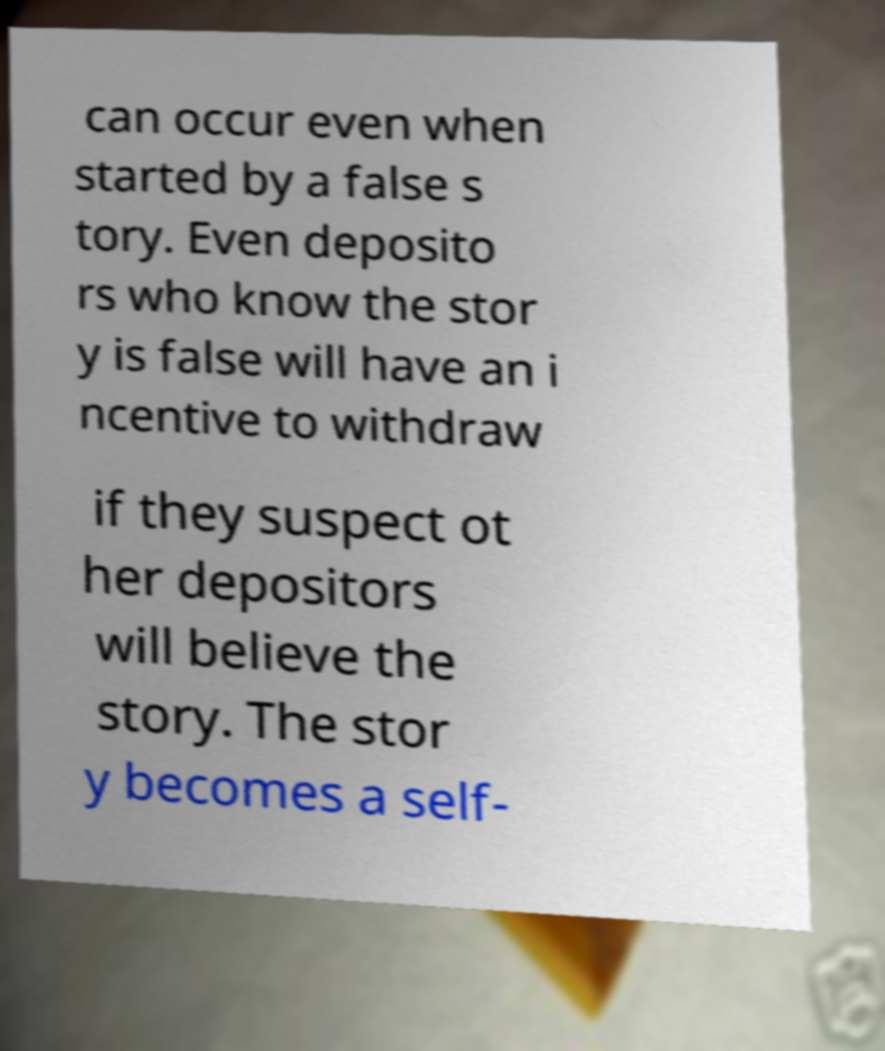Can you read and provide the text displayed in the image?This photo seems to have some interesting text. Can you extract and type it out for me? can occur even when started by a false s tory. Even deposito rs who know the stor y is false will have an i ncentive to withdraw if they suspect ot her depositors will believe the story. The stor y becomes a self- 